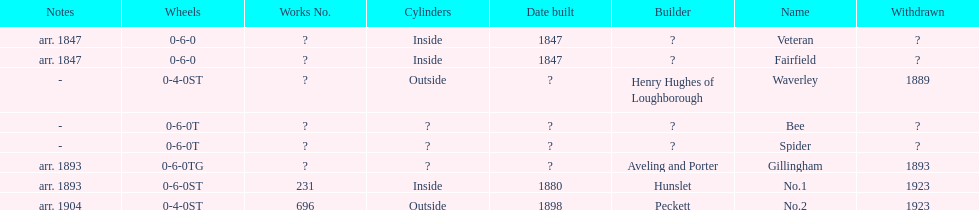What is the total number of names on the chart? 8. 